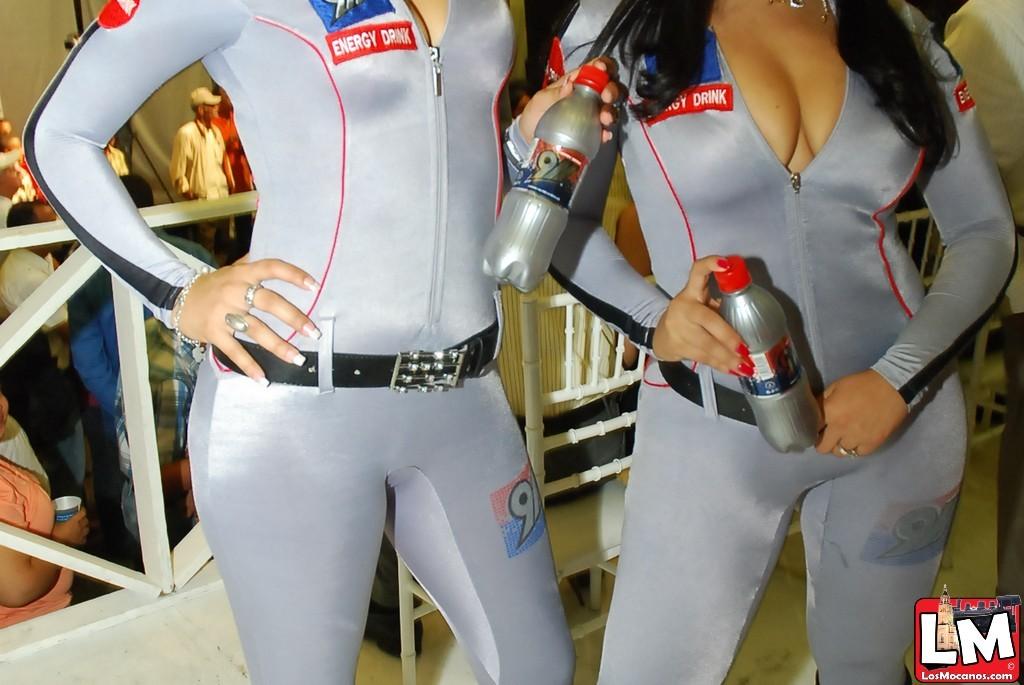What type of drink is being advertised?
Make the answer very short. Energy drink. What website is shown on the bottom right of the image?
Provide a succinct answer. Losmocanos.com. 